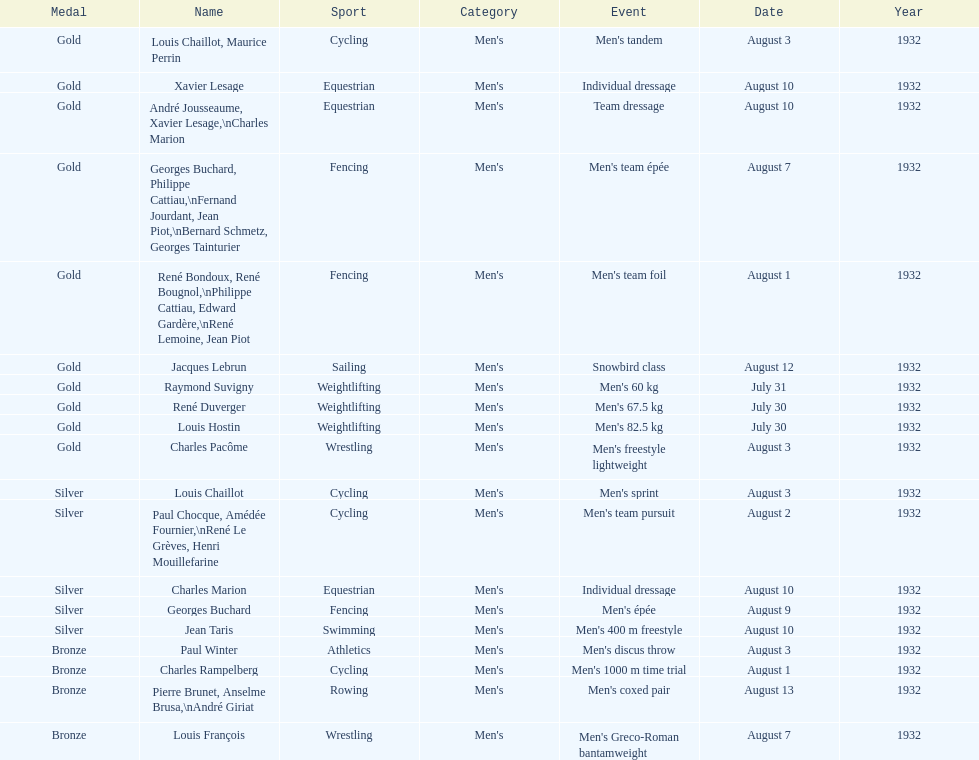What event is listed right before team dressage? Individual dressage. 